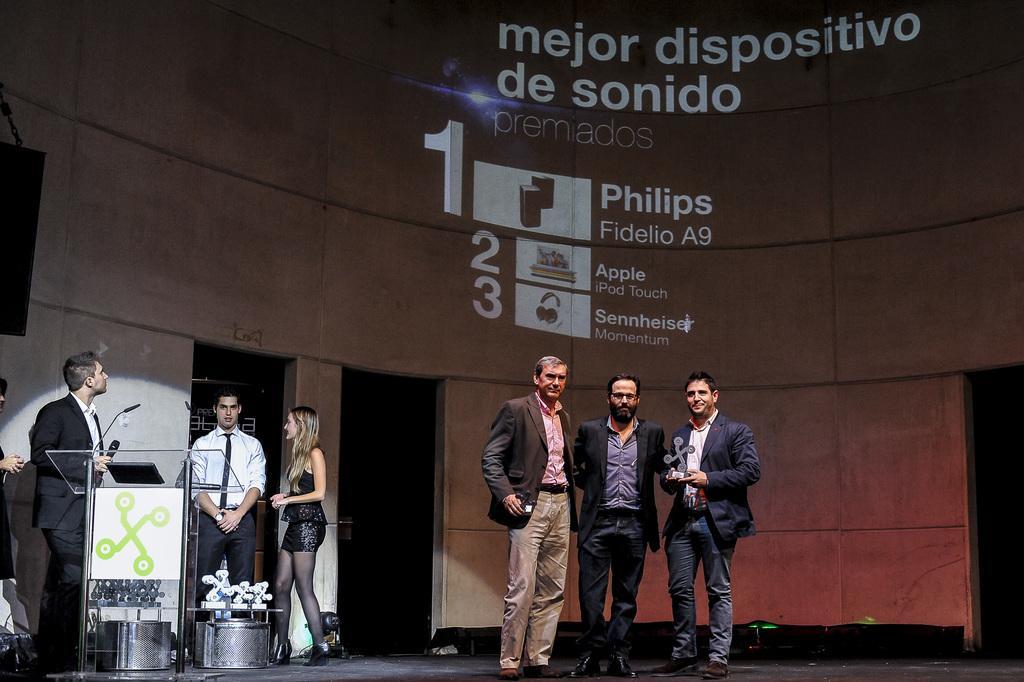In one or two sentences, can you explain what this image depicts? In the foreground, I can see a group of people are standing on the stage and are holding some objects in their hand. On the left, I can see a table and some objects. In the background, I can see a screen, doors and a wall. This image taken, maybe in a hall. 